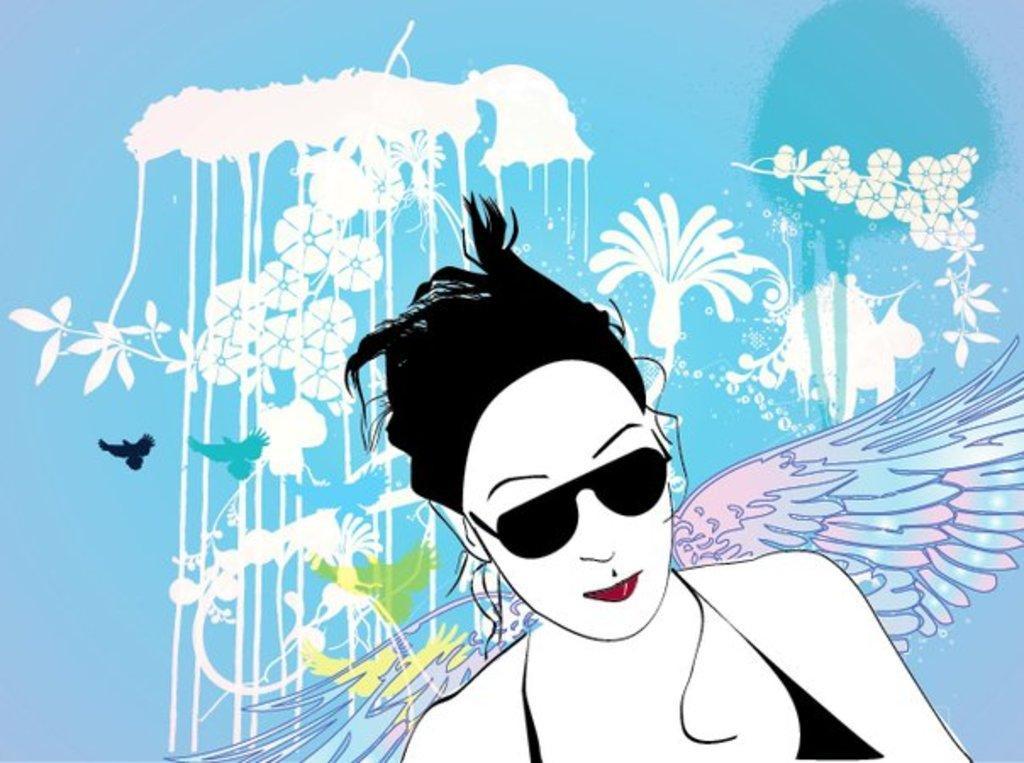Could you give a brief overview of what you see in this image? This is an animation, in this image there is one woman who is wearing goggles and there are wings flowers. And in the background there is some art, and there is blue color background. 